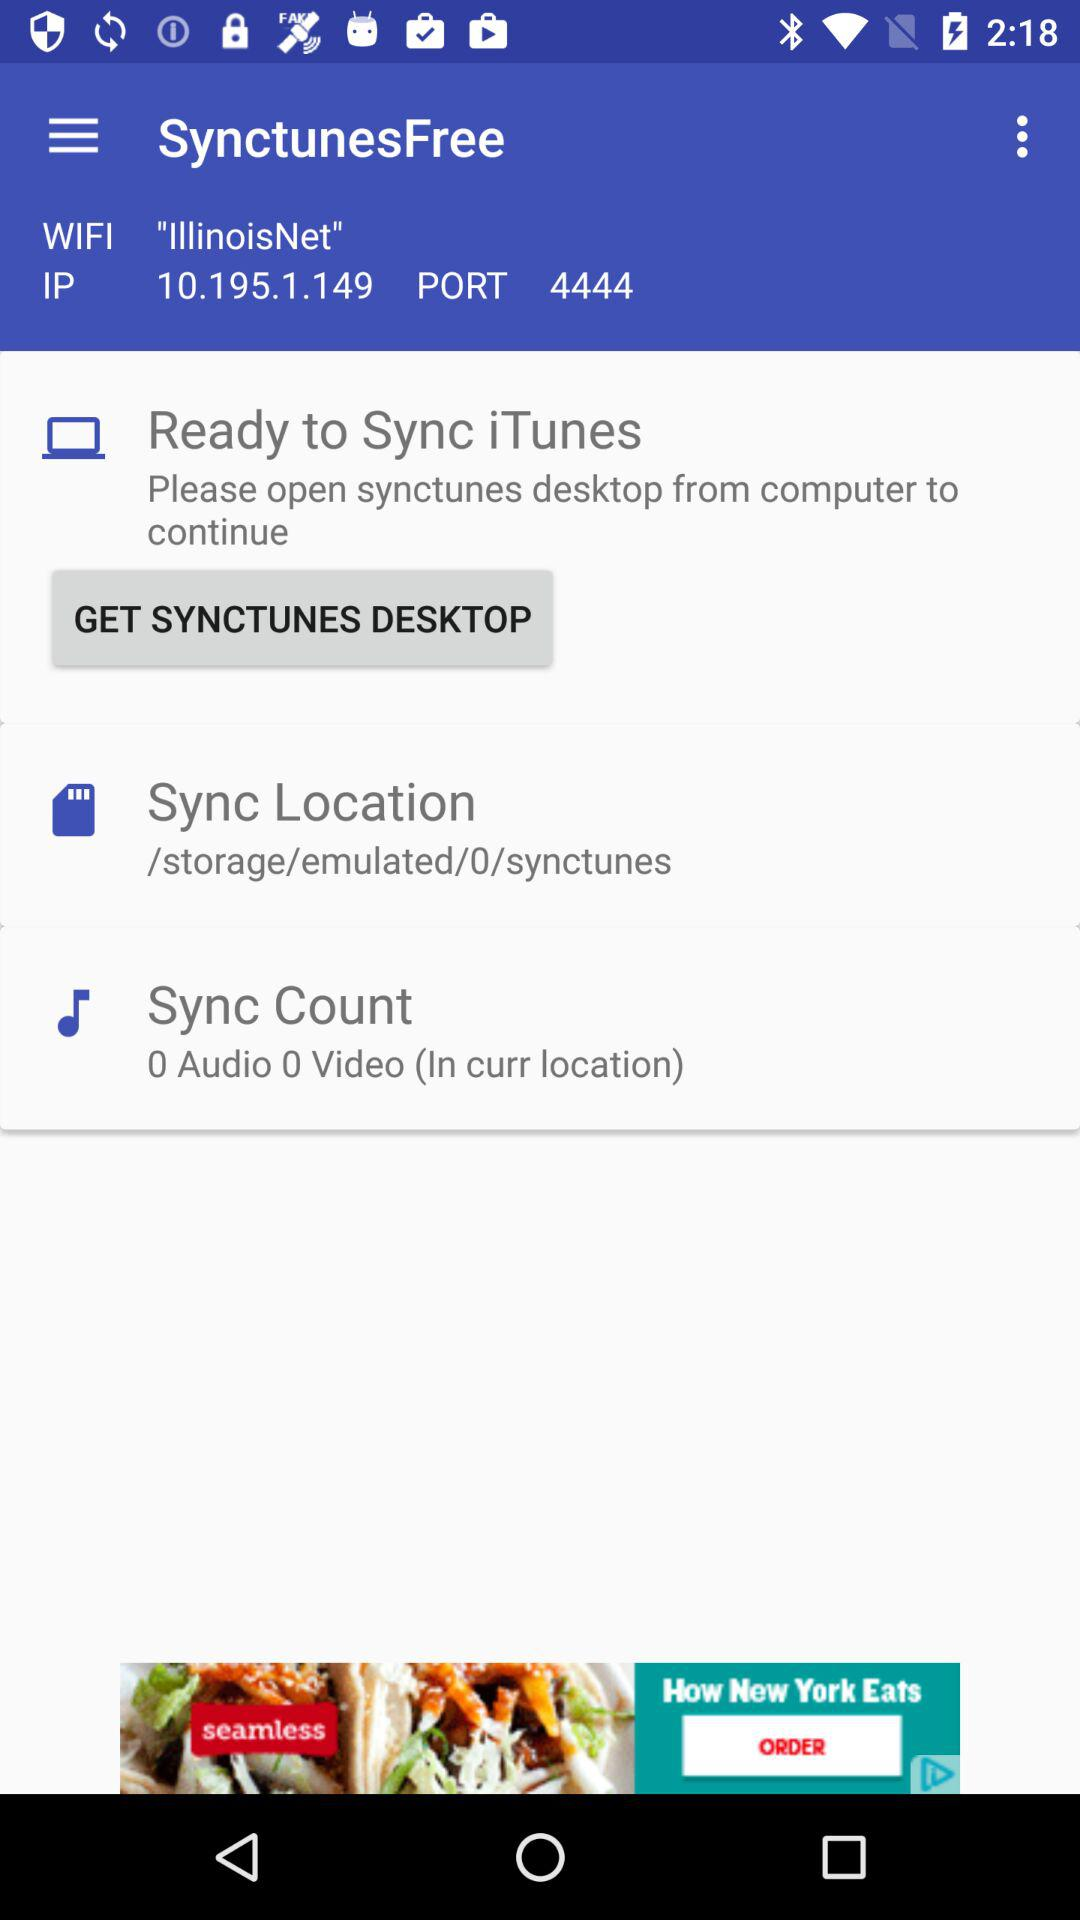What is the IP address? The IP address is 10.195.1.149. 